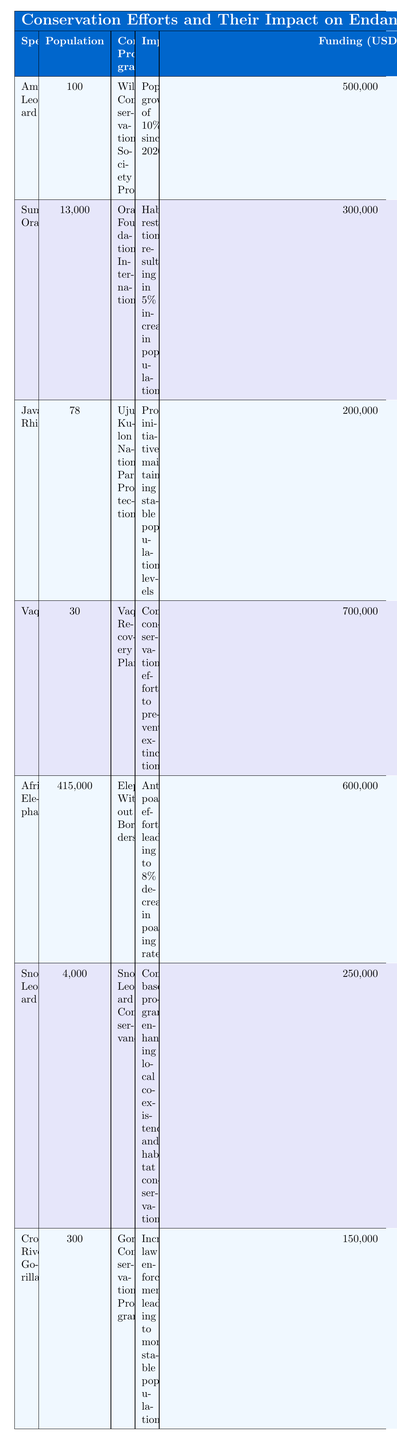What is the population estimate of the Amur Leopard? The table shows the population estimate of the Amur Leopard listed in the relevant column. According to the table, it is 100.
Answer: 100 Which conservation program has the highest funding? By comparing the funding amounts across all species in the table, the Vaquita Recovery Plan is associated with the highest funding of 700,000 USD.
Answer: 700,000 USD How much did the African Elephant population decrease in poaching rates due to conservation efforts? The table indicates that anti-poaching efforts led to an 8% decrease in poaching rates for African Elephants.
Answer: 8% What is the total population estimate of the three species with the highest populations? The species with the highest populations are the African Elephant (415,000), Sumatran Orangutan (13,000), and Snow Leopard (4,000). Adding these gives 415,000 + 13,000 + 4,000 = 432,000.
Answer: 432,000 Did the Javan Rhino experience a population increase from conservation efforts? The table states that protection initiatives have maintained stable population levels for the Javan Rhino, which implies no increase.
Answer: No Which species has a population estimate closest to 300? The Cross River Gorilla has a population estimate of 300, which matches the requested criteria.
Answer: Cross River Gorilla In which region is the Vaquita found? The table specifies that the Vaquita is located in the Gulf of California, Mexico.
Answer: Gulf of California, Mexico What is the average funding amount for the conservation programs listed? The funding amounts can be calculated as follows: (500,000 + 300,000 + 200,000 + 700,000 + 600,000 + 250,000 + 150,000) / 7 = 300,000. Therefore, the average funding amount is 300,000 USD.
Answer: 300,000 USD How many species have a population estimate below 100? The table shows that the Amur Leopard (100), Javan Rhino (78), and Vaquita (30) have population estimates below 100. The Javan Rhino and Vaquita fit this requirement, totaling 2 species.
Answer: 2 Is there a conservation program that has successfully increased the population of its species? Yes, the Sumatran Orangutan's conservation program resulted in a 5% increase in population according to the table.
Answer: Yes Which species have conservation impacts connected to community-based programs? The Snow Leopard is associated with community-based programs aimed at enhancing local coexistence and habitat conservation, as noted in the table.
Answer: Snow Leopard 